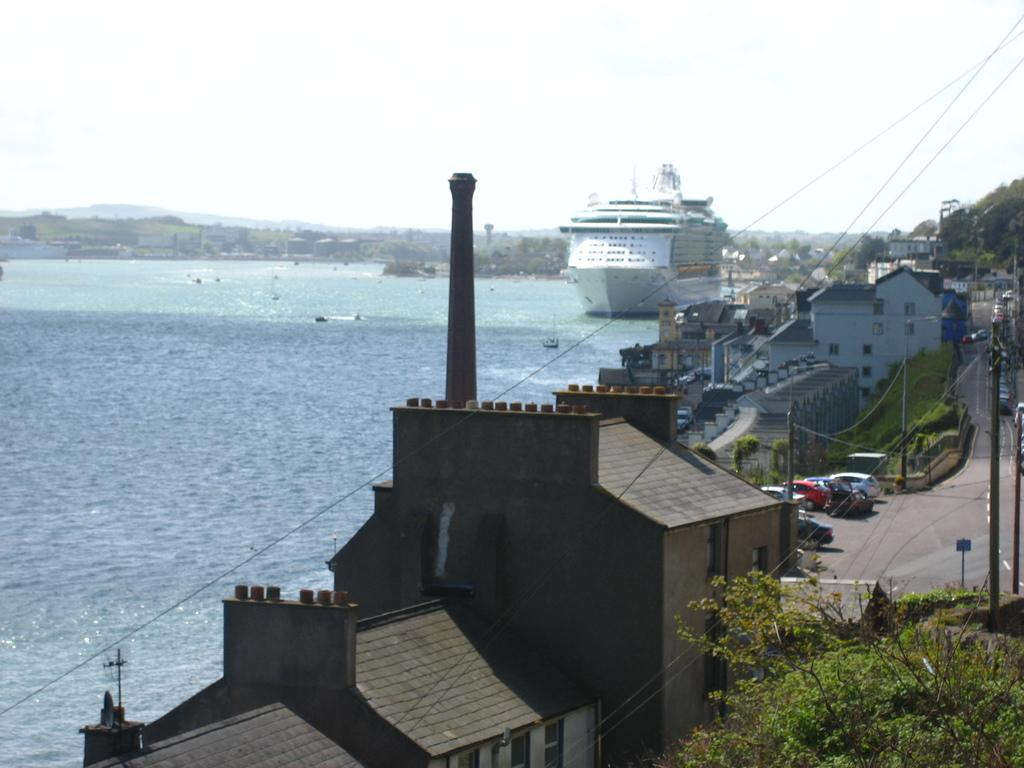What type of structures can be seen in the image? There are buildings in the image. What architectural features can be observed on the buildings? Windows are visible in the image. What natural elements are present in the image? There are trees in the image. What man-made objects are related to electricity in the image? Current-poles and wires are present in the image. What type of signage is visible in the image? Sign boards are present in the image. What mode of transportation can be seen in the image? There are vehicles on the road in the image. What type of water-based vehicle is visible in the image? A white ship is visible in the image. What type of terrain is present in the image? Water is present in the image. What is the color of the sky in the image? The sky is white in color. How many horses are grazing in the water in the image? There are no horses present in the image. What type of rice can be seen growing near the water in the image? There is no rice present in the image. 